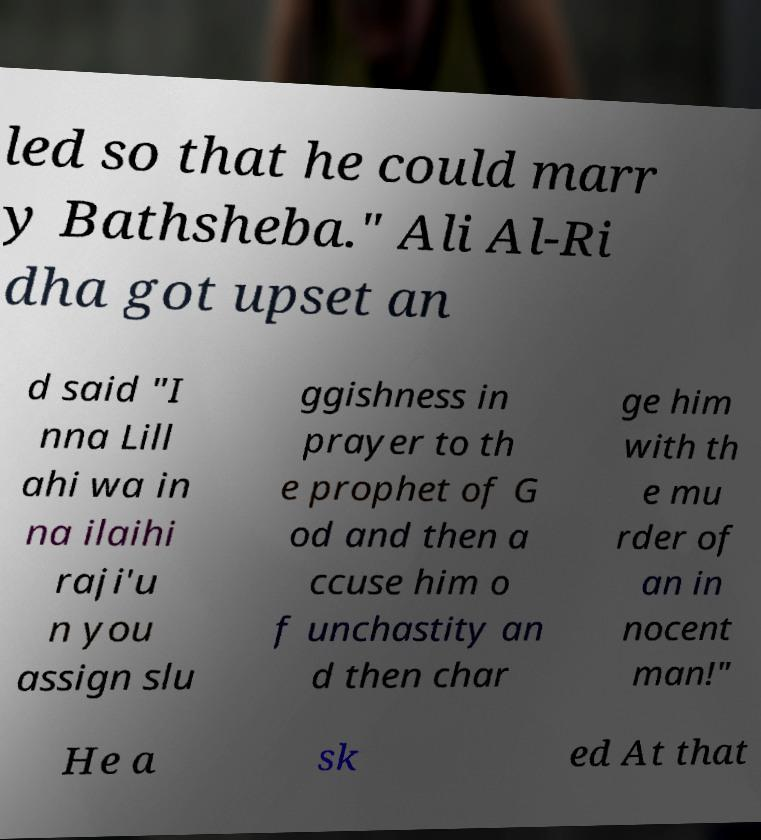What messages or text are displayed in this image? I need them in a readable, typed format. led so that he could marr y Bathsheba." Ali Al-Ri dha got upset an d said "I nna Lill ahi wa in na ilaihi raji'u n you assign slu ggishness in prayer to th e prophet of G od and then a ccuse him o f unchastity an d then char ge him with th e mu rder of an in nocent man!" He a sk ed At that 